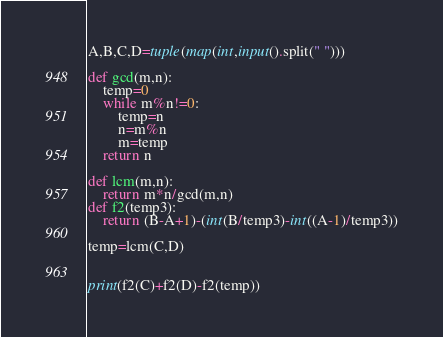<code> <loc_0><loc_0><loc_500><loc_500><_Python_>A,B,C,D=tuple(map(int,input().split(" ")))

def gcd(m,n):
    temp=0
    while m%n!=0:
        temp=n
        n=m%n
        m=temp
    return n

def lcm(m,n):
    return m*n/gcd(m,n)
def f2(temp3):
    return (B-A+1)-(int(B/temp3)-int((A-1)/temp3))

temp=lcm(C,D)


print(f2(C)+f2(D)-f2(temp))
</code> 